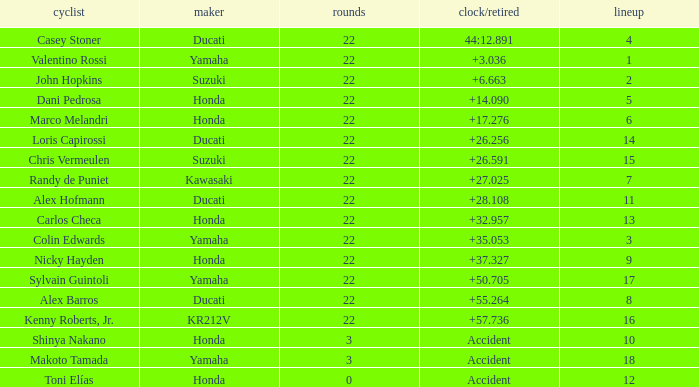What was the average amount of laps for competitors with a grid that was more than 11 and a Time/Retired of +28.108? None. 